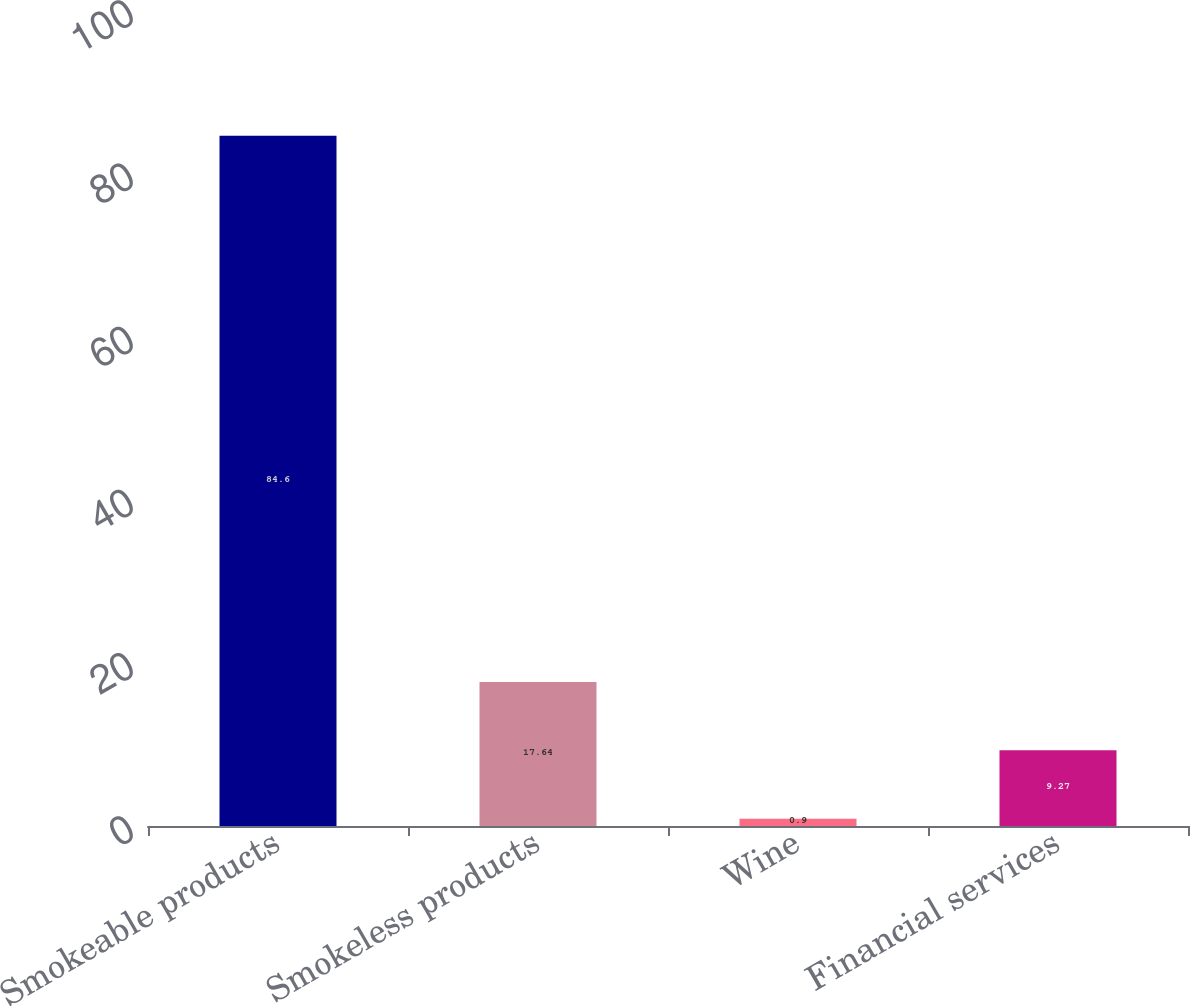Convert chart to OTSL. <chart><loc_0><loc_0><loc_500><loc_500><bar_chart><fcel>Smokeable products<fcel>Smokeless products<fcel>Wine<fcel>Financial services<nl><fcel>84.6<fcel>17.64<fcel>0.9<fcel>9.27<nl></chart> 